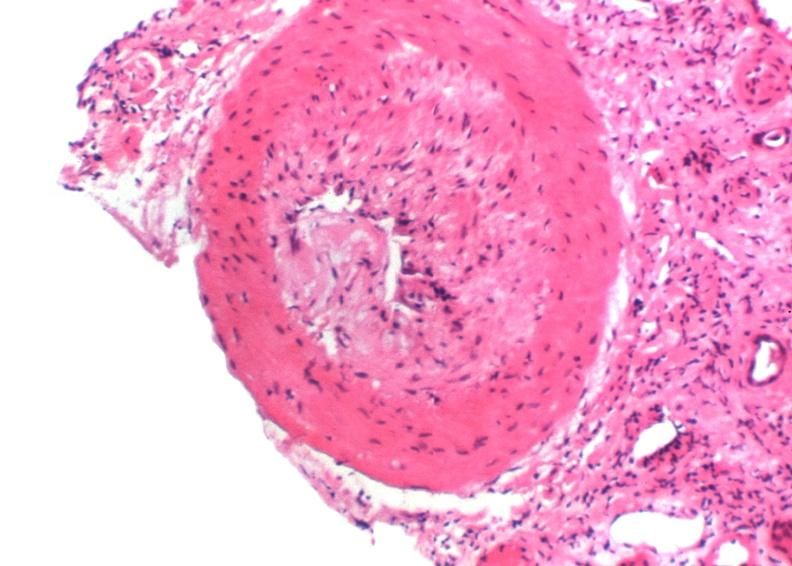where is this?
Answer the question using a single word or phrase. Urinary 